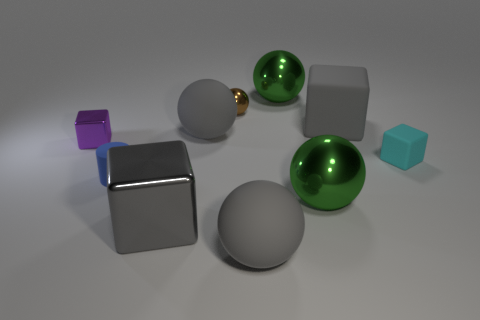How many tiny matte cylinders have the same color as the big matte cube?
Provide a short and direct response. 0. There is a cyan rubber block behind the big metal sphere on the right side of the big green shiny ball that is behind the small blue matte cylinder; what is its size?
Make the answer very short. Small. What number of matte things are either purple blocks or yellow spheres?
Make the answer very short. 0. Is the shape of the big gray shiny thing the same as the tiny rubber thing to the right of the tiny brown shiny ball?
Offer a very short reply. Yes. Are there more large rubber things right of the brown shiny ball than gray things that are left of the small blue cylinder?
Your answer should be very brief. Yes. Are there any other things of the same color as the tiny shiny ball?
Keep it short and to the point. No. Is there a tiny purple object that is right of the large green thing behind the gray block that is to the right of the tiny brown object?
Your answer should be very brief. No. Does the big rubber thing that is in front of the tiny purple object have the same shape as the brown object?
Provide a short and direct response. Yes. Is the number of big metallic cubes that are behind the small cyan thing less than the number of tiny cylinders on the left side of the purple metal cube?
Offer a terse response. No. What material is the blue object?
Your response must be concise. Rubber. 